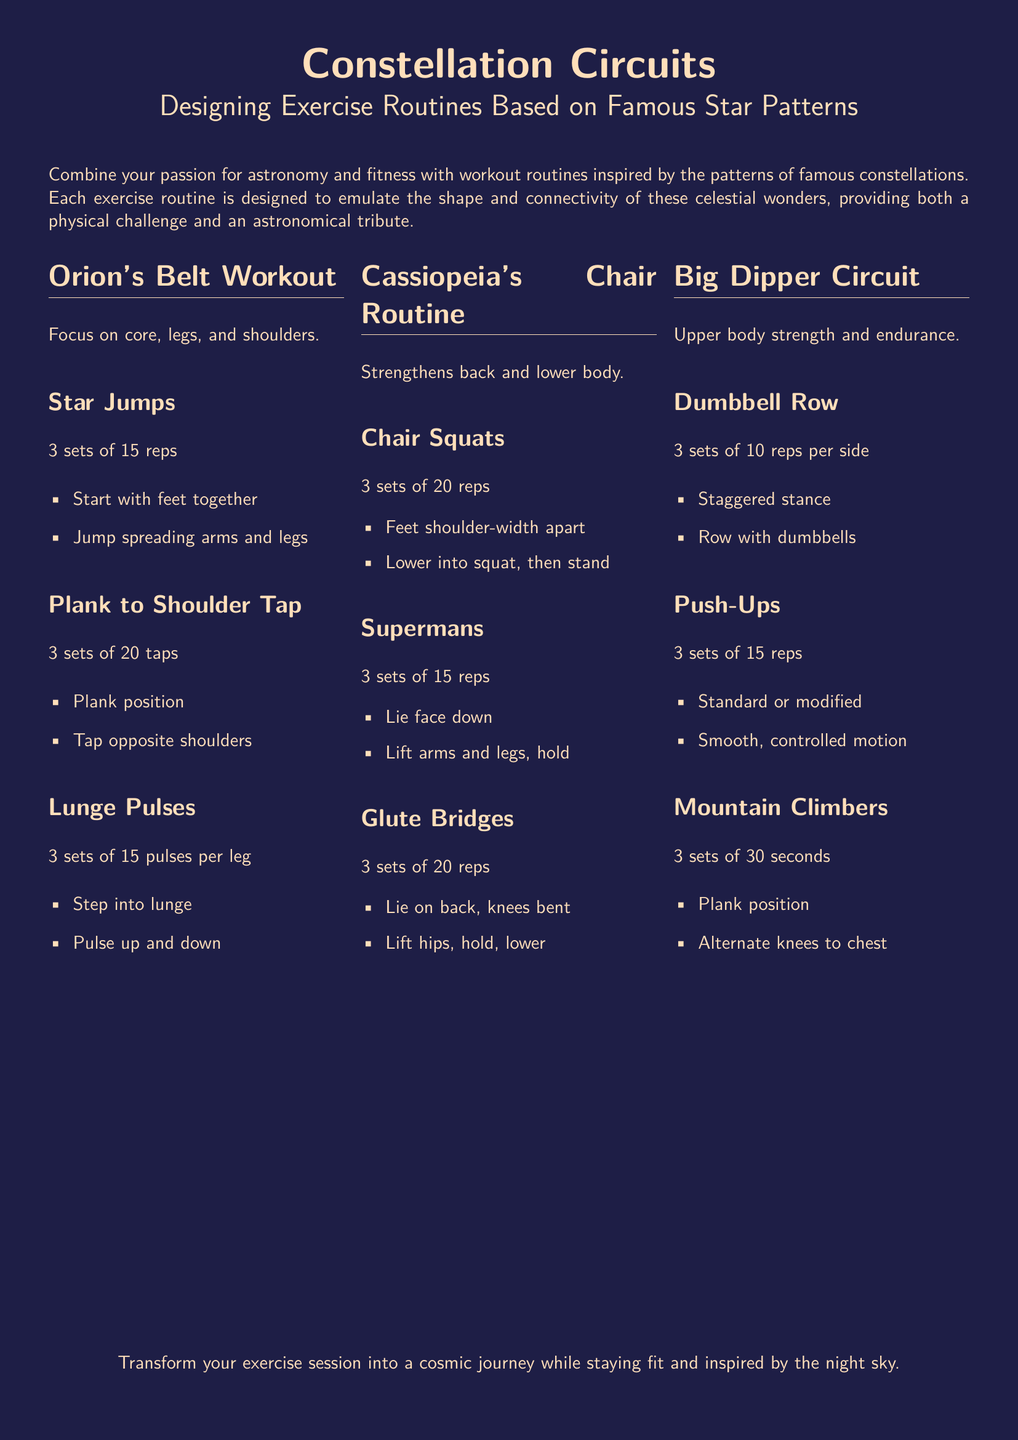What is the title of the workout plan? The title of the workout plan is presented prominently at the beginning of the document.
Answer: Constellation Circuits How many sets of Star Jumps are suggested? The document specifies the number of sets for each exercise in the routines.
Answer: 3 sets What muscle groups does Orion's Belt Workout focus on? The document lists the focus areas for each workout routine clearly.
Answer: Core, legs, and shoulders Which exercise is included in Cassiopeia's Chair Routine? The document provides a list of exercises for each routine, highlighting specific exercises.
Answer: Chair Squats What is the duration for Mountain Climbers in the Big Dipper Circuit? The document states the time associated with the Mountain Climbers exercise.
Answer: 30 seconds What type of exercise is a Supermans? The document categorizes exercises into different types and provides details on each.
Answer: Strength How many reps are suggested for Plank to Shoulder Tap? The workout recommendations include specific repetitions for each exercise.
Answer: 20 taps Which constellation is associated with glute strength in the routines? The document links exercise routines to specific constellations for thematic integration.
Answer: Cassiopeia What is the last statement in the document? The conclusion summarizes the purpose of the workout plan.
Answer: Transform your exercise session into a cosmic journey while staying fit and inspired by the night sky 